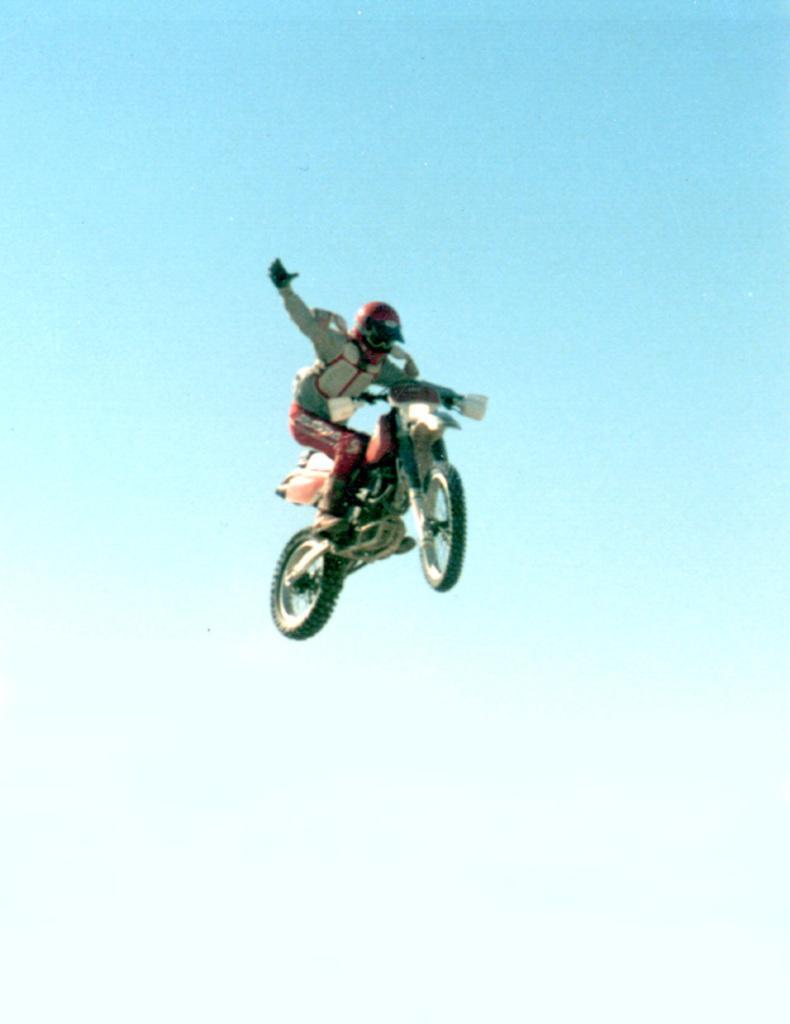Can you describe this image briefly? In this image there is a man performing stunt on the bike which is in the air. 